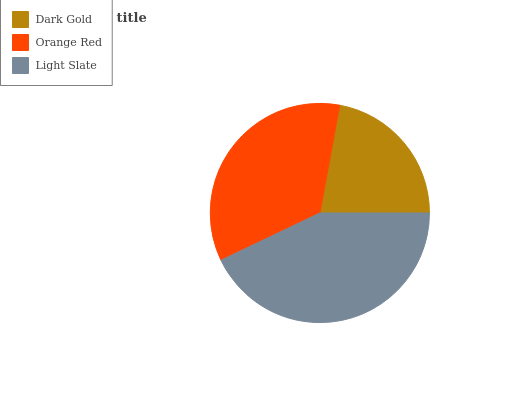Is Dark Gold the minimum?
Answer yes or no. Yes. Is Light Slate the maximum?
Answer yes or no. Yes. Is Orange Red the minimum?
Answer yes or no. No. Is Orange Red the maximum?
Answer yes or no. No. Is Orange Red greater than Dark Gold?
Answer yes or no. Yes. Is Dark Gold less than Orange Red?
Answer yes or no. Yes. Is Dark Gold greater than Orange Red?
Answer yes or no. No. Is Orange Red less than Dark Gold?
Answer yes or no. No. Is Orange Red the high median?
Answer yes or no. Yes. Is Orange Red the low median?
Answer yes or no. Yes. Is Light Slate the high median?
Answer yes or no. No. Is Light Slate the low median?
Answer yes or no. No. 